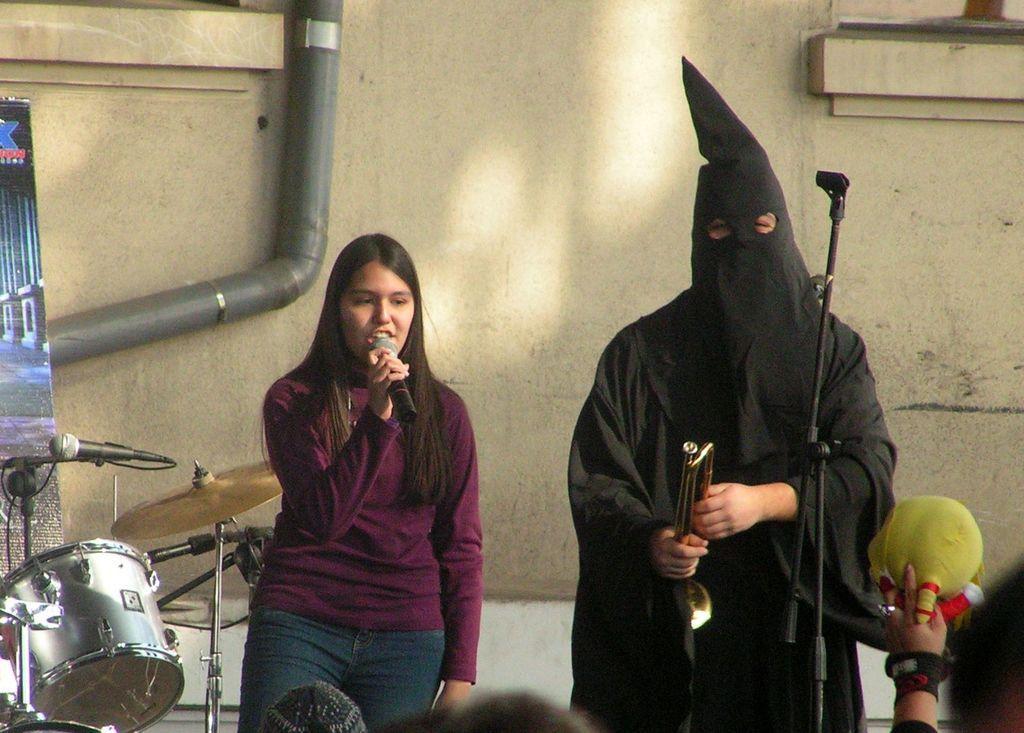Describe this image in one or two sentences. In this image I see a woman who is holding a mic and there is a person side to her and the person is holding a musical instrument and there are few people over here, I can also see that there is a drum over here. In the background I see the wall and the pipe. 